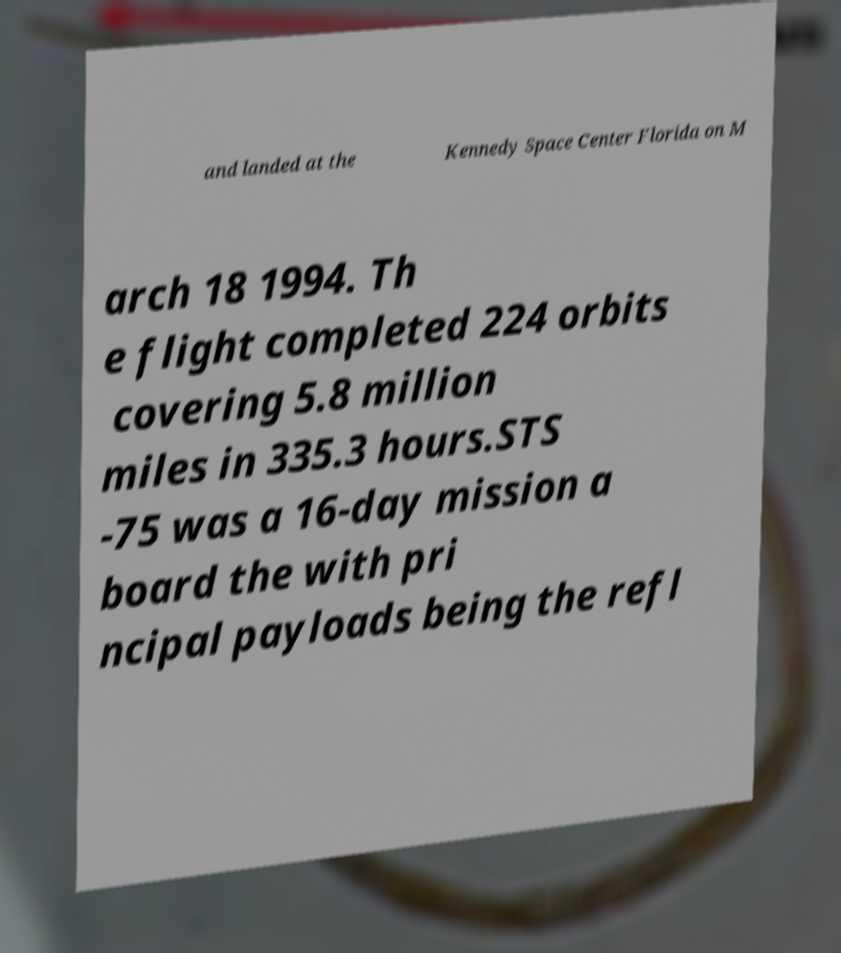Could you extract and type out the text from this image? and landed at the Kennedy Space Center Florida on M arch 18 1994. Th e flight completed 224 orbits covering 5.8 million miles in 335.3 hours.STS -75 was a 16-day mission a board the with pri ncipal payloads being the refl 